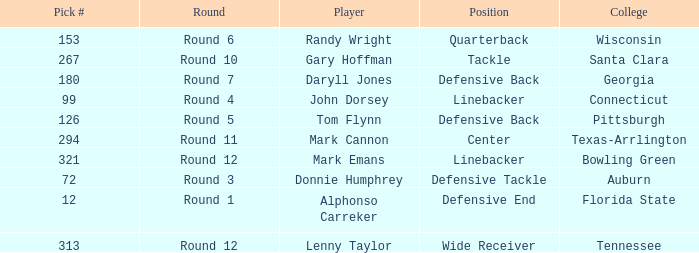Could you help me parse every detail presented in this table? {'header': ['Pick #', 'Round', 'Player', 'Position', 'College'], 'rows': [['153', 'Round 6', 'Randy Wright', 'Quarterback', 'Wisconsin'], ['267', 'Round 10', 'Gary Hoffman', 'Tackle', 'Santa Clara'], ['180', 'Round 7', 'Daryll Jones', 'Defensive Back', 'Georgia'], ['99', 'Round 4', 'John Dorsey', 'Linebacker', 'Connecticut'], ['126', 'Round 5', 'Tom Flynn', 'Defensive Back', 'Pittsburgh'], ['294', 'Round 11', 'Mark Cannon', 'Center', 'Texas-Arrlington'], ['321', 'Round 12', 'Mark Emans', 'Linebacker', 'Bowling Green'], ['72', 'Round 3', 'Donnie Humphrey', 'Defensive Tackle', 'Auburn'], ['12', 'Round 1', 'Alphonso Carreker', 'Defensive End', 'Florida State'], ['313', 'Round 12', 'Lenny Taylor', 'Wide Receiver', 'Tennessee']]} What is Mark Cannon's College? Texas-Arrlington. 